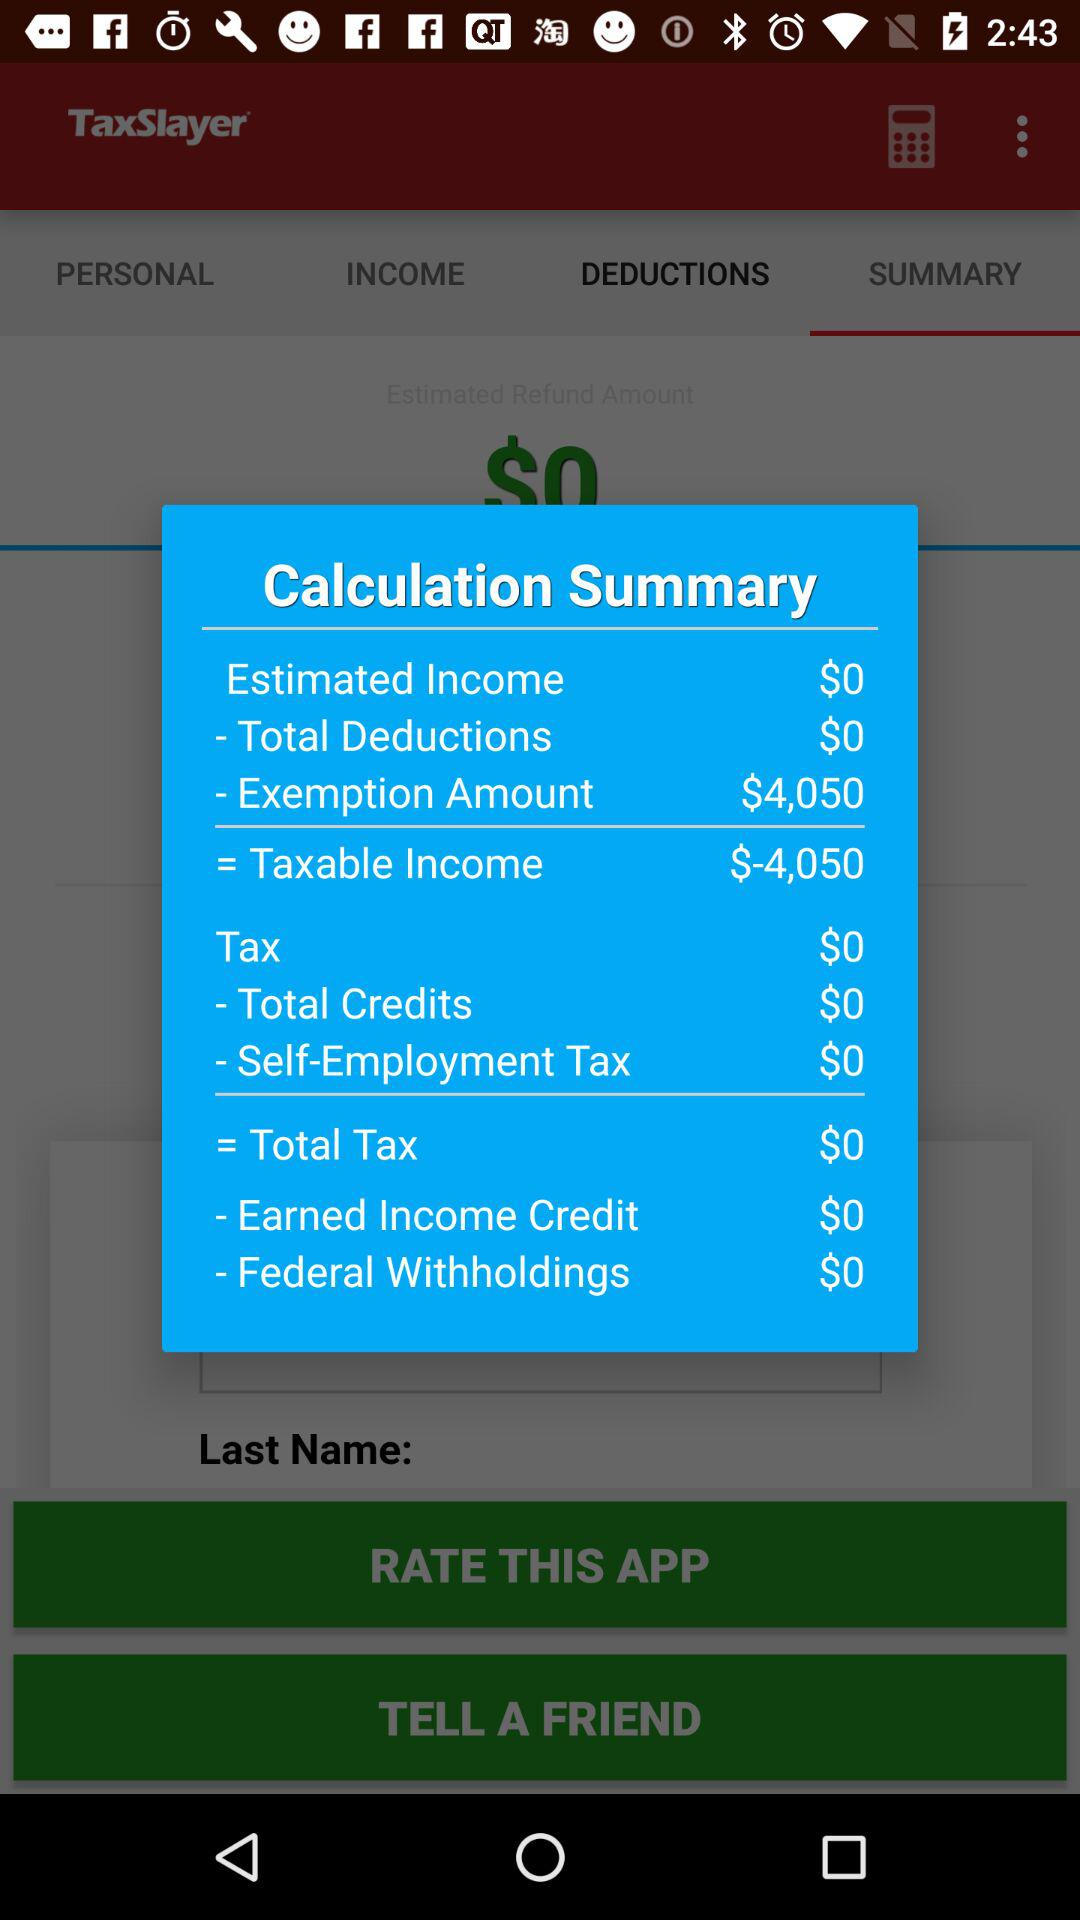How much is the total credit amount? The total credit amount is $0. 